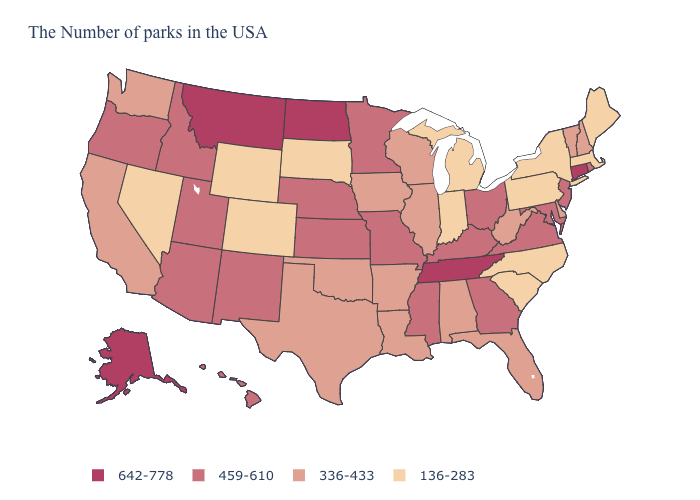Is the legend a continuous bar?
Be succinct. No. Among the states that border Idaho , does Utah have the lowest value?
Answer briefly. No. Is the legend a continuous bar?
Give a very brief answer. No. Among the states that border Florida , which have the highest value?
Quick response, please. Georgia. Does Alaska have the highest value in the USA?
Keep it brief. Yes. Among the states that border Tennessee , which have the highest value?
Concise answer only. Virginia, Georgia, Kentucky, Mississippi, Missouri. What is the lowest value in states that border Wisconsin?
Give a very brief answer. 136-283. Does Massachusetts have the lowest value in the USA?
Write a very short answer. Yes. Does Kentucky have a higher value than Maryland?
Short answer required. No. What is the lowest value in states that border Texas?
Keep it brief. 336-433. Does Colorado have the lowest value in the USA?
Keep it brief. Yes. Does Illinois have a lower value than Minnesota?
Keep it brief. Yes. What is the lowest value in states that border Maine?
Write a very short answer. 336-433. Name the states that have a value in the range 459-610?
Concise answer only. Rhode Island, New Jersey, Maryland, Virginia, Ohio, Georgia, Kentucky, Mississippi, Missouri, Minnesota, Kansas, Nebraska, New Mexico, Utah, Arizona, Idaho, Oregon, Hawaii. Does Wyoming have the lowest value in the USA?
Keep it brief. Yes. 